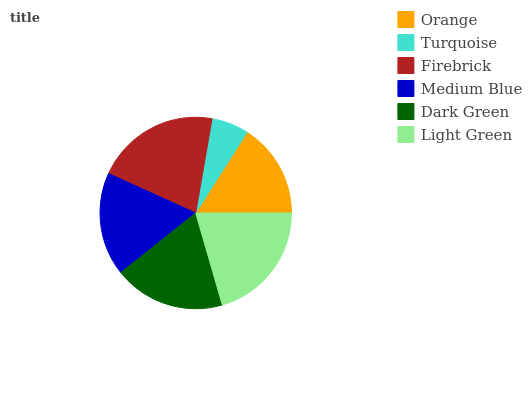Is Turquoise the minimum?
Answer yes or no. Yes. Is Firebrick the maximum?
Answer yes or no. Yes. Is Firebrick the minimum?
Answer yes or no. No. Is Turquoise the maximum?
Answer yes or no. No. Is Firebrick greater than Turquoise?
Answer yes or no. Yes. Is Turquoise less than Firebrick?
Answer yes or no. Yes. Is Turquoise greater than Firebrick?
Answer yes or no. No. Is Firebrick less than Turquoise?
Answer yes or no. No. Is Dark Green the high median?
Answer yes or no. Yes. Is Medium Blue the low median?
Answer yes or no. Yes. Is Medium Blue the high median?
Answer yes or no. No. Is Turquoise the low median?
Answer yes or no. No. 